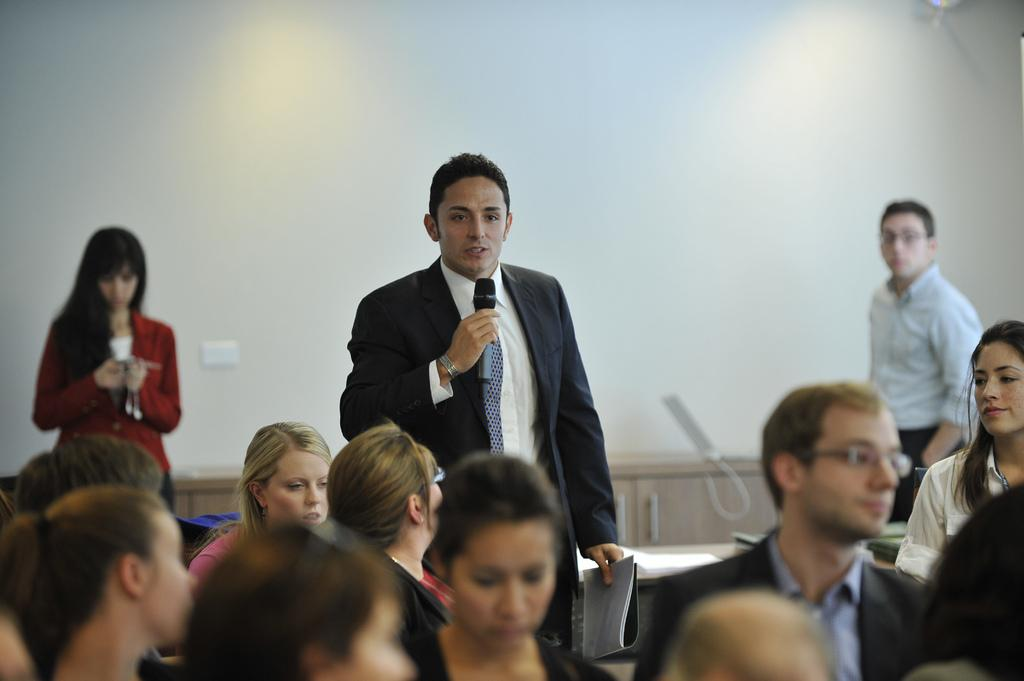How many people are in the image? There are persons in the image, but the exact number is not specified. What is the person holding in the image? One person is holding a microphone and a book in the image. What can be seen in the background of the image? There is a wall in the background of the image. What is located in front of the wall? There is a table in front of the wall. What type of growth can be seen on the wall in the image? There is no mention of growth on the wall in the image. 